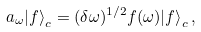Convert formula to latex. <formula><loc_0><loc_0><loc_500><loc_500>a _ { \omega } { | } f { \rangle } _ { c } = ( \delta \omega ) ^ { 1 / 2 } f ( \omega ) { | } f { \rangle } _ { c } \, ,</formula> 